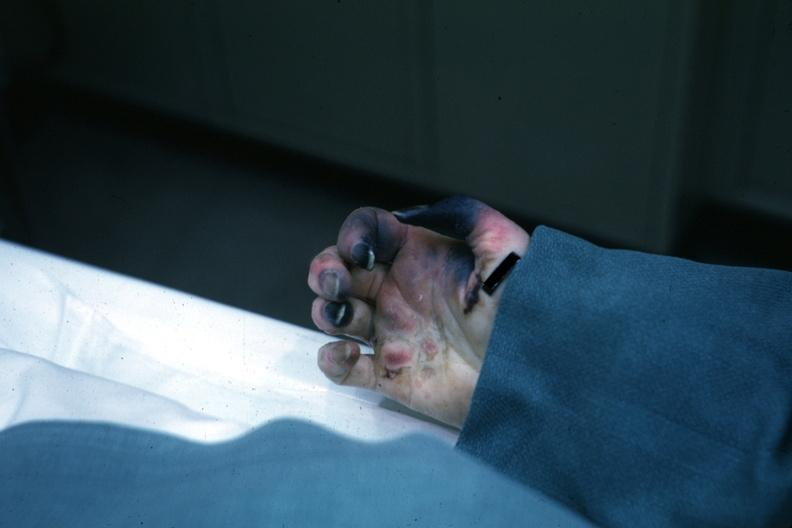re extremities present?
Answer the question using a single word or phrase. Yes 